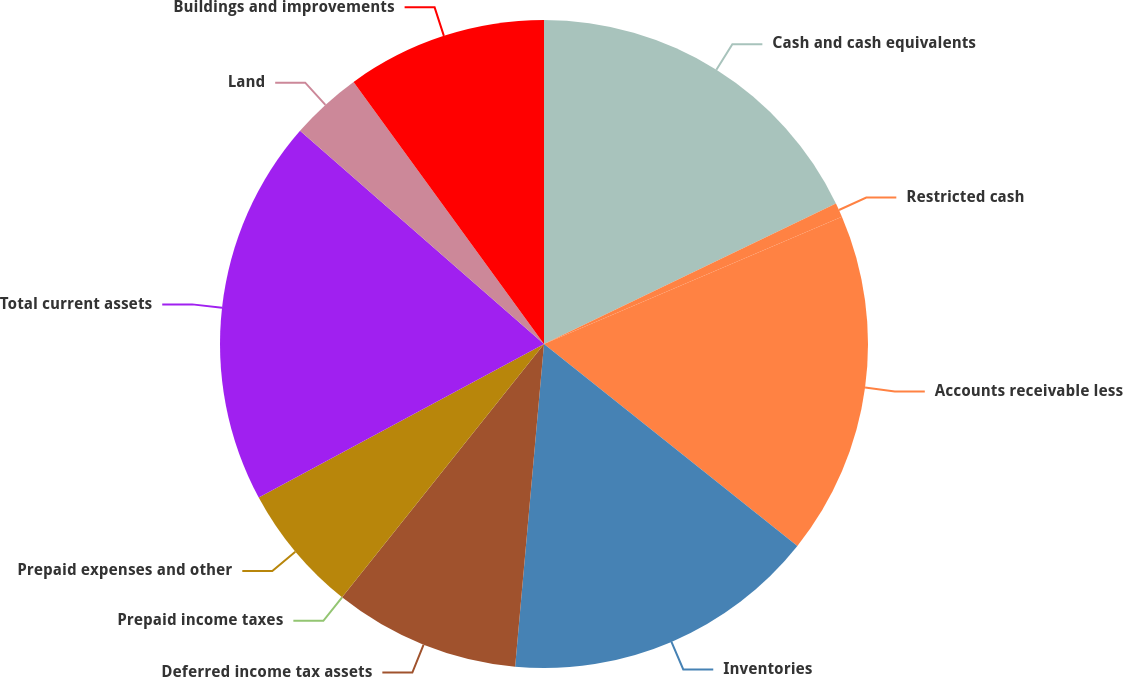Convert chart. <chart><loc_0><loc_0><loc_500><loc_500><pie_chart><fcel>Cash and cash equivalents<fcel>Restricted cash<fcel>Accounts receivable less<fcel>Inventories<fcel>Deferred income tax assets<fcel>Prepaid income taxes<fcel>Prepaid expenses and other<fcel>Total current assets<fcel>Land<fcel>Buildings and improvements<nl><fcel>17.86%<fcel>0.71%<fcel>17.14%<fcel>15.71%<fcel>9.29%<fcel>0.0%<fcel>6.43%<fcel>19.29%<fcel>3.57%<fcel>10.0%<nl></chart> 